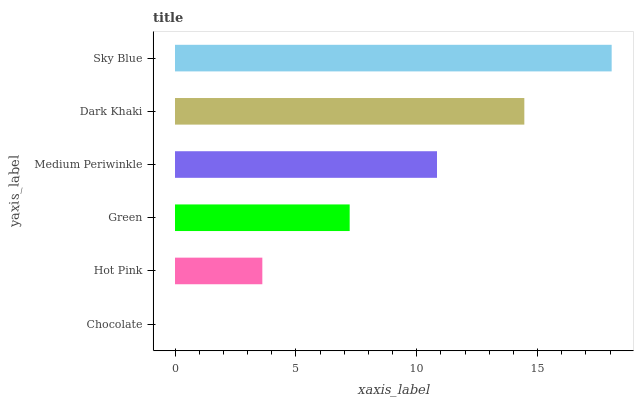Is Chocolate the minimum?
Answer yes or no. Yes. Is Sky Blue the maximum?
Answer yes or no. Yes. Is Hot Pink the minimum?
Answer yes or no. No. Is Hot Pink the maximum?
Answer yes or no. No. Is Hot Pink greater than Chocolate?
Answer yes or no. Yes. Is Chocolate less than Hot Pink?
Answer yes or no. Yes. Is Chocolate greater than Hot Pink?
Answer yes or no. No. Is Hot Pink less than Chocolate?
Answer yes or no. No. Is Medium Periwinkle the high median?
Answer yes or no. Yes. Is Green the low median?
Answer yes or no. Yes. Is Sky Blue the high median?
Answer yes or no. No. Is Sky Blue the low median?
Answer yes or no. No. 